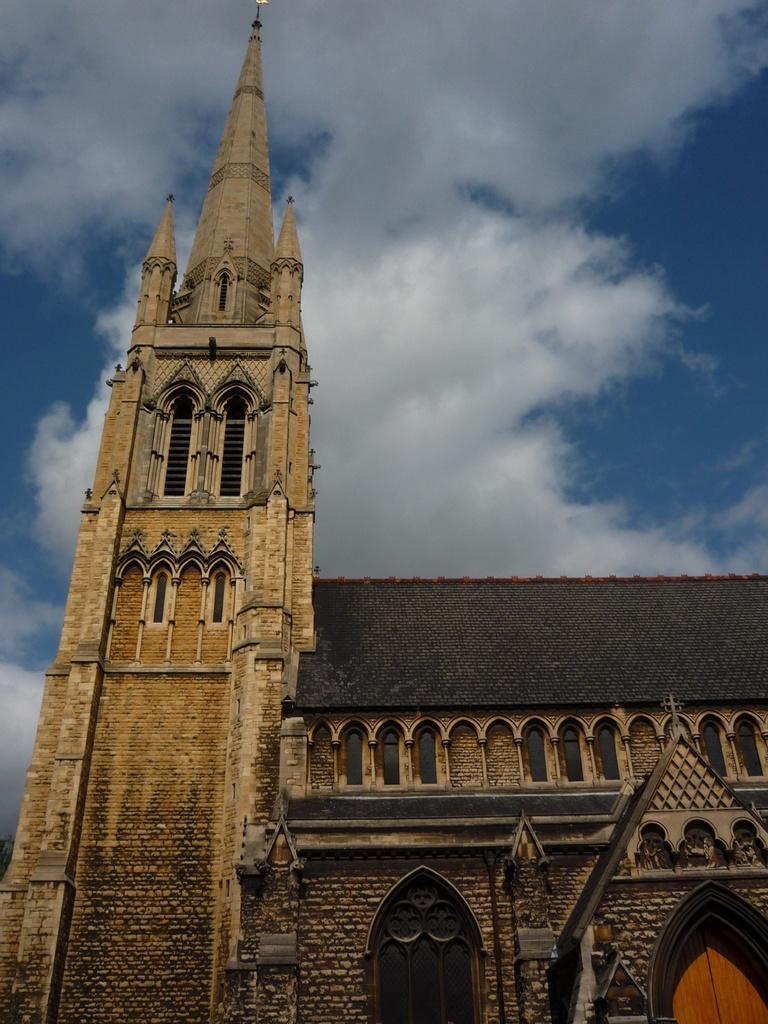Describe this image in one or two sentences. In this picture I can see building and a blue cloudy sky. 